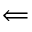<formula> <loc_0><loc_0><loc_500><loc_500>\Longleftarrow</formula> 